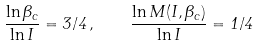Convert formula to latex. <formula><loc_0><loc_0><loc_500><loc_500>\frac { \ln \Theta _ { c } } { \ln I } = 3 / 4 \, , \quad \frac { \ln M ( I , \Theta _ { c } ) } { \ln I } = 1 / 4</formula> 